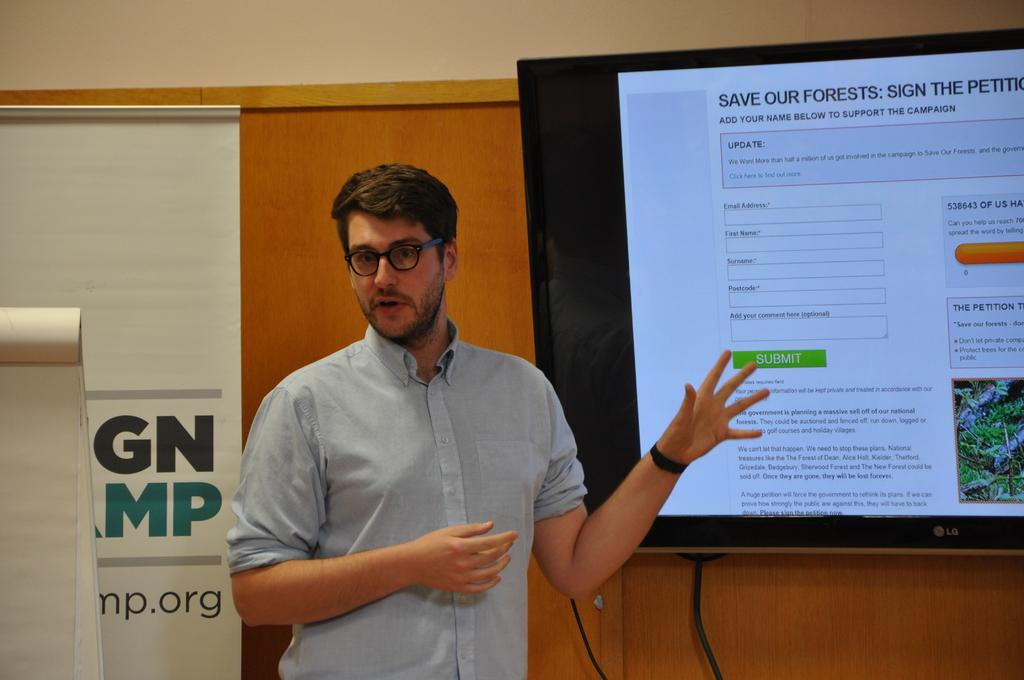Who is present in the image? There is a man in the image. What is the man wearing in the image? The man is wearing spectacles in the image. What can be seen in the background of the image? There is a television, wires, posters, and a wall in the background of the image. What type of box is the man using to store his summer clothes in the image? There is no box or mention of summer clothes in the image. 